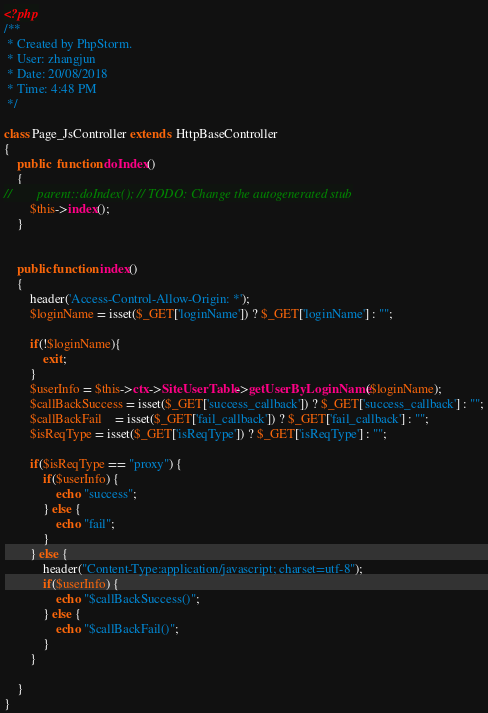<code> <loc_0><loc_0><loc_500><loc_500><_PHP_><?php
/**
 * Created by PhpStorm.
 * User: zhangjun
 * Date: 20/08/2018
 * Time: 4:48 PM
 */

class Page_JsController extends  HttpBaseController
{
    public  function doIndex()
    {
//        parent::doIndex(); // TODO: Change the autogenerated stub
        $this->index();
    }


    public function index()
    {
        header('Access-Control-Allow-Origin: *');
        $loginName = isset($_GET['loginName']) ? $_GET['loginName'] : "";

        if(!$loginName){
            exit;
        }
        $userInfo = $this->ctx->SiteUserTable->getUserByLoginName($loginName);
        $callBackSuccess = isset($_GET['success_callback']) ? $_GET['success_callback'] : "";
        $callBackFail    = isset($_GET['fail_callback']) ? $_GET['fail_callback'] : "";
        $isReqType = isset($_GET['isReqType']) ? $_GET['isReqType'] : "";

        if($isReqType == "proxy") {
            if($userInfo) {
                echo "success";
            } else {
                echo "fail";
            }
        } else {
            header("Content-Type:application/javascript; charset=utf-8");
            if($userInfo) {
                echo "$callBackSuccess()";
            } else {
                echo "$callBackFail()";
            }
        }

    }
}</code> 